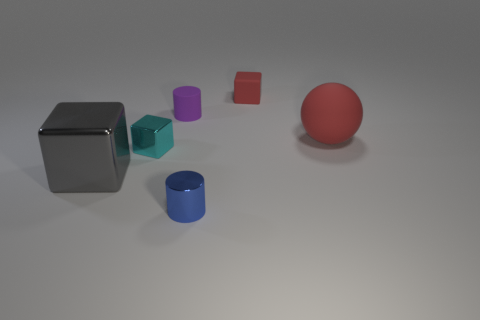There is a object that is the same color as the large rubber ball; what is its size?
Offer a terse response. Small. Does the blue cylinder have the same size as the purple matte object?
Your answer should be compact. Yes. What number of objects are either big red rubber objects or red rubber objects that are in front of the small red matte thing?
Your answer should be compact. 1. What number of objects are either tiny rubber things in front of the red cube or small blocks on the left side of the tiny metal cylinder?
Offer a very short reply. 2. Are there any tiny metallic objects on the right side of the tiny red rubber object?
Offer a very short reply. No. The small cylinder that is behind the small shiny thing that is left of the shiny object that is in front of the big gray shiny object is what color?
Give a very brief answer. Purple. Does the large matte thing have the same shape as the tiny cyan thing?
Offer a very short reply. No. There is a big object that is the same material as the blue cylinder; what color is it?
Make the answer very short. Gray. How many objects are red spheres behind the small blue metal object or small shiny things?
Your answer should be compact. 3. What is the size of the cylinder that is on the left side of the blue thing?
Make the answer very short. Small. 